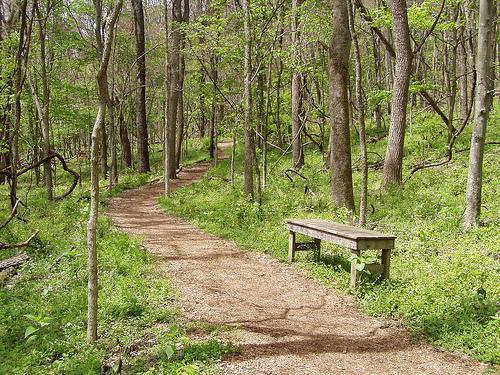How many benches are there?
Give a very brief answer. 1. 